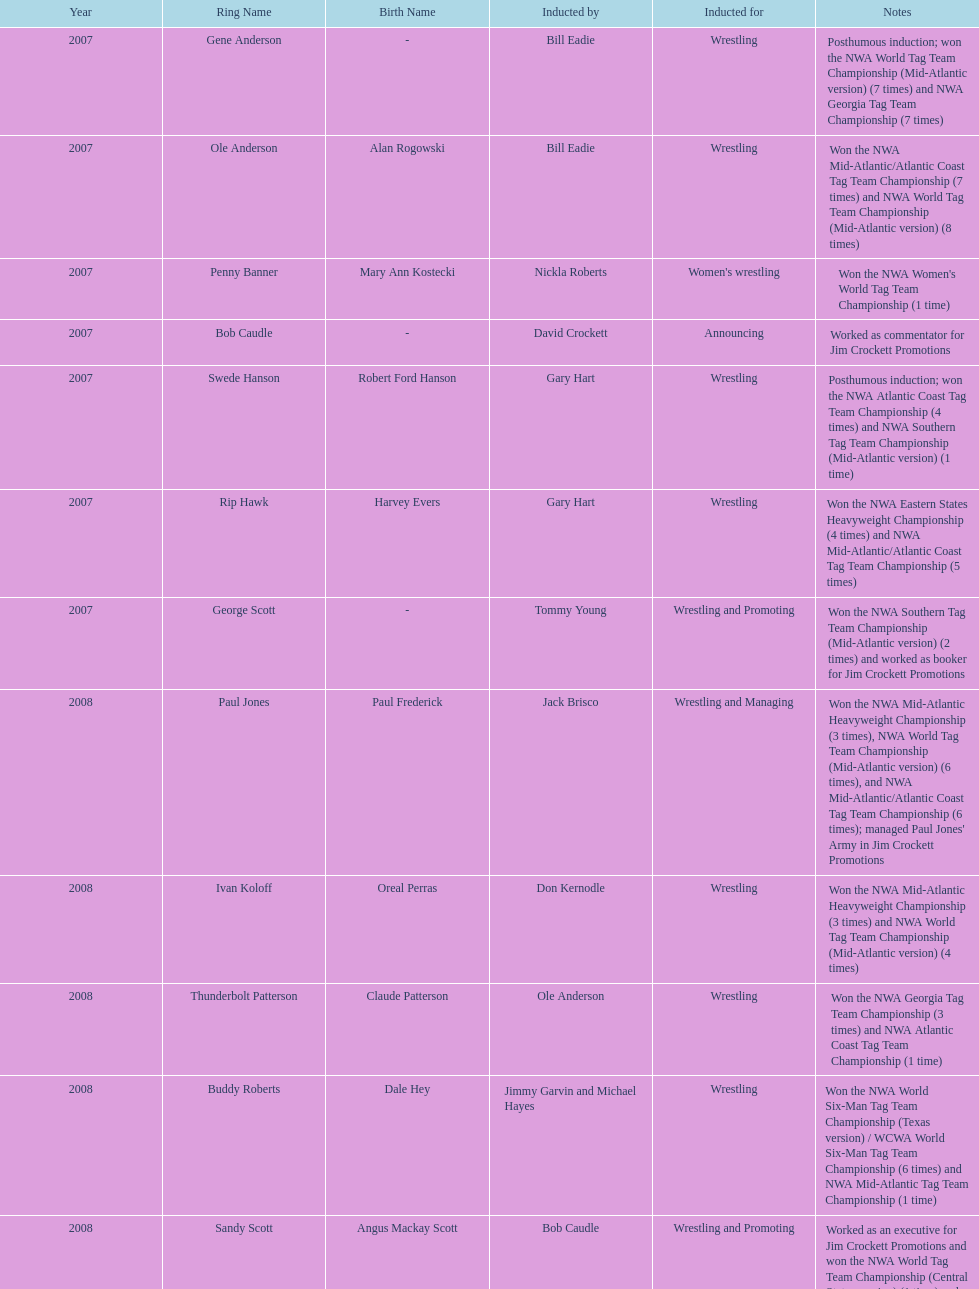Tell me an inductee that was not living at the time. Gene Anderson. 